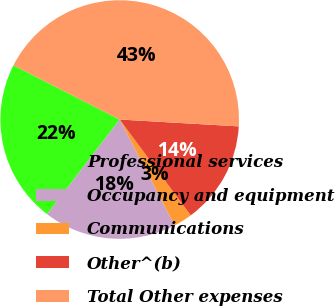<chart> <loc_0><loc_0><loc_500><loc_500><pie_chart><fcel>Professional services<fcel>Occupancy and equipment<fcel>Communications<fcel>Other^(b)<fcel>Total Other expenses<nl><fcel>22.11%<fcel>18.02%<fcel>2.54%<fcel>13.93%<fcel>43.4%<nl></chart> 